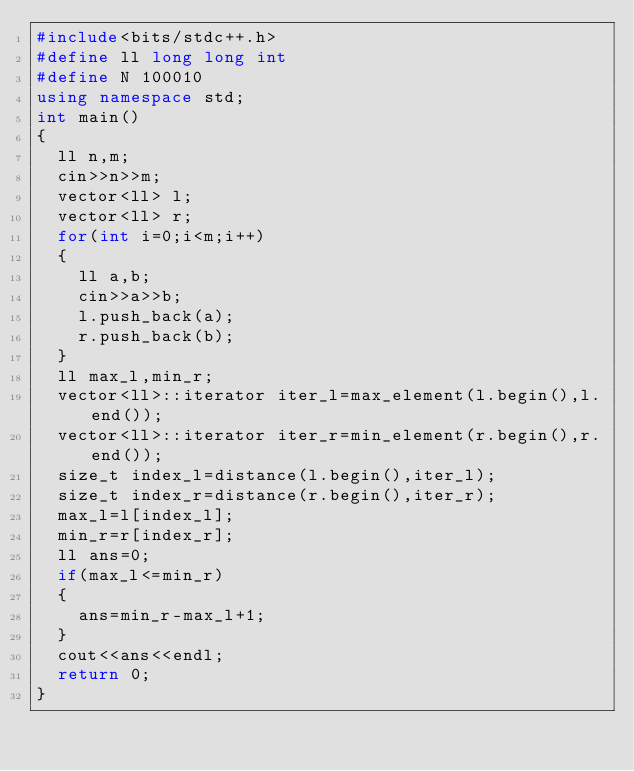<code> <loc_0><loc_0><loc_500><loc_500><_C++_>#include<bits/stdc++.h>
#define ll long long int
#define N 100010
using namespace std;
int main() 
{
	ll n,m;
	cin>>n>>m;
	vector<ll> l;
	vector<ll> r;
	for(int i=0;i<m;i++)
	{
		ll a,b;
		cin>>a>>b;
		l.push_back(a);
		r.push_back(b);
	}
	ll max_l,min_r;
	vector<ll>::iterator iter_l=max_element(l.begin(),l.end());
	vector<ll>::iterator iter_r=min_element(r.begin(),r.end());
	size_t index_l=distance(l.begin(),iter_l);
	size_t index_r=distance(r.begin(),iter_r);
	max_l=l[index_l];
	min_r=r[index_r];
	ll ans=0;
	if(max_l<=min_r)
	{
		ans=min_r-max_l+1;
	}
	cout<<ans<<endl;
	return 0;
}</code> 